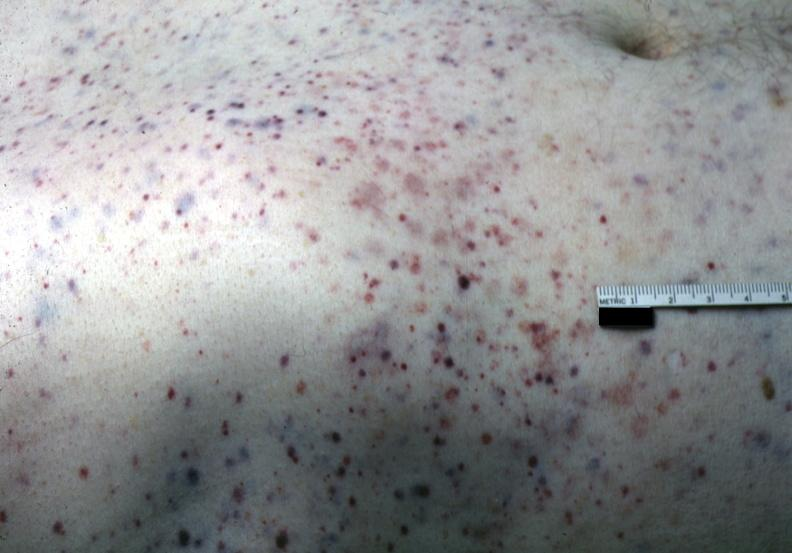where is this?
Answer the question using a single word or phrase. Skin 